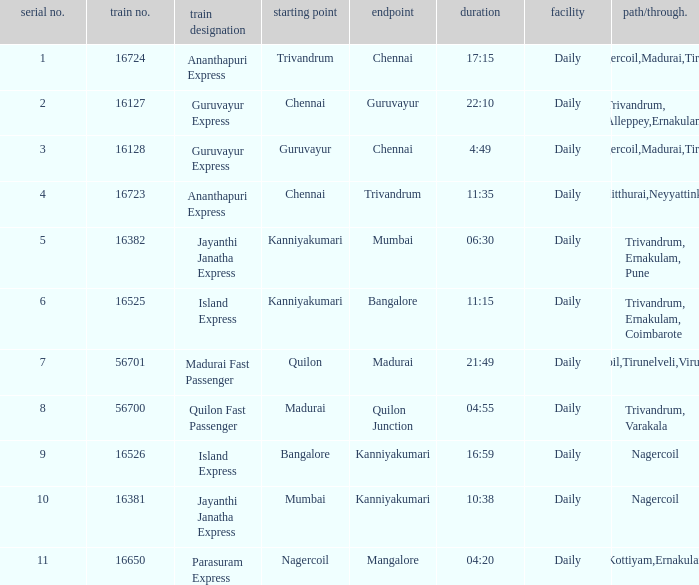What is the origin when the destination is Mumbai? Kanniyakumari. 